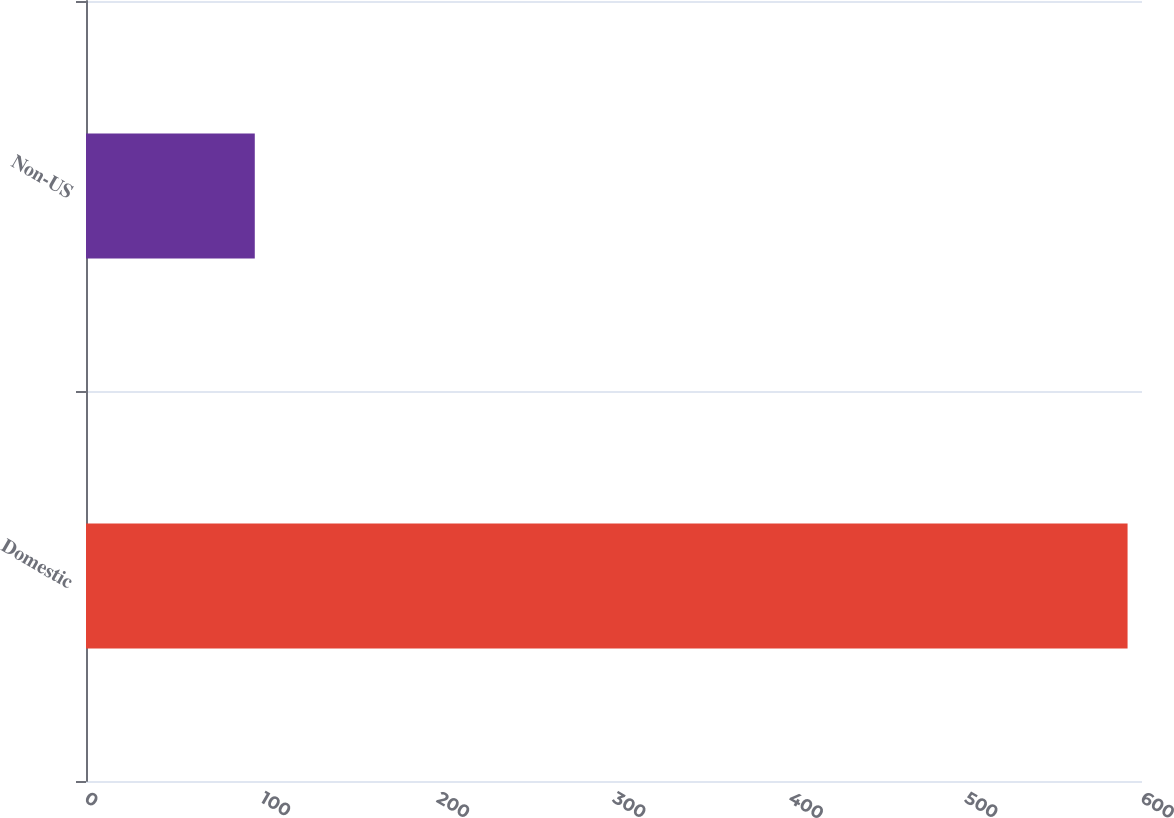Convert chart. <chart><loc_0><loc_0><loc_500><loc_500><bar_chart><fcel>Domestic<fcel>Non-US<nl><fcel>591.8<fcel>95.9<nl></chart> 